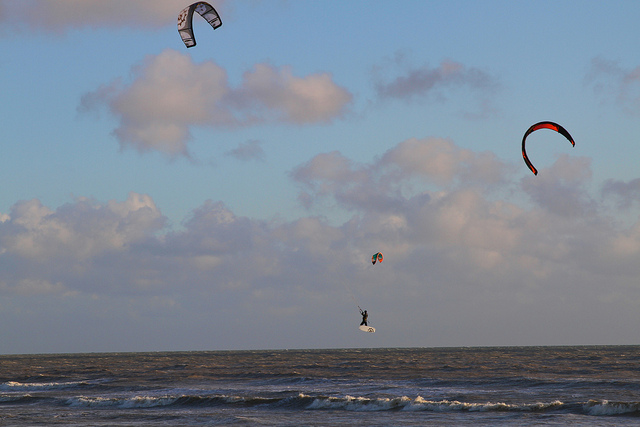Can you describe the main objects you see in the image? In the image, I observe a vast expanse of the sea with waves near the shoreline. Above the sea, there are multiple kites flying, and I also notice someone on what appears to be a surfboard or kiteboard in the water, possibly kite surfing. How many kites can you count in the image? There are three kites visible in the image. Are there any humans visible in the image? Yes, there is one person visible in the image, who appears to be kite surfing on the water. Where is the kite surfer located in relation to the kites? The kite surfer is positioned below and between two of the flying kites, closer to the shoreline. One kite is directly above them, while another kite is to their right. What is the background of the image? The background of the image showcases a vast ocean or sea with waves near the shoreline. Above the water, there's a sky with scattered clouds. Are there any mountains or cityscapes in the background? No, there are no mountains or cityscapes visible in the image's background. Can you explain the sport of kite surfing to me, based on what you see? Certainly! Kite surfing, also known as kiteboarding, is a water sport that combines aspects of surfing, wakeboarding, and windsurfing. A participant stands on a small surfboard or kiteboard and is propelled across the water by a large, controllable kite. The kite is attached to the surfer by a harness, and the surfer holds onto a bar which allows them to control the kite's direction and power. The image depicts a kite surfer in action, with the kite being used to catch the wind and pull the surfer across the water. It's a dynamic and exhilarating sport that requires a mix of balance, strength, and understanding of wind conditions. Given the kites' positions and the surfer's movement, what can you infer about the wind direction? Based on the positions of the kites and their angles, it seems the wind is coming from the left side of the image, pushing the kites to the right. The kite surfer's trajectory also suggests they are moving with the wind coming from their left, which further indicates the same wind direction. 